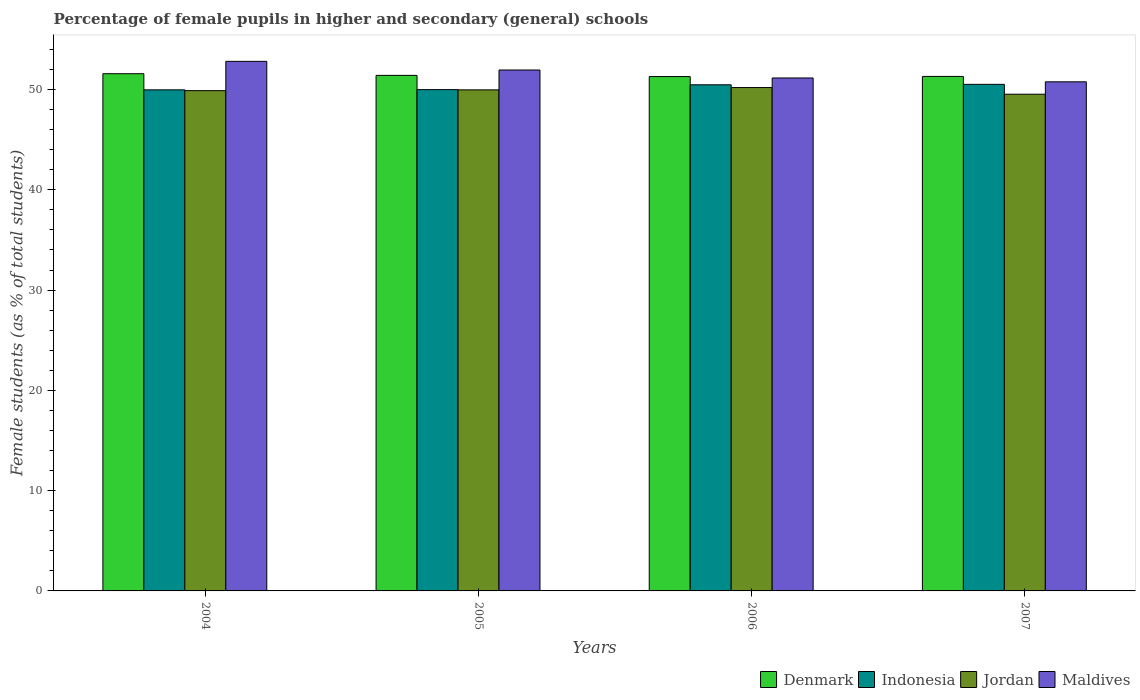How many different coloured bars are there?
Give a very brief answer. 4. Are the number of bars per tick equal to the number of legend labels?
Offer a terse response. Yes. Are the number of bars on each tick of the X-axis equal?
Ensure brevity in your answer.  Yes. What is the label of the 1st group of bars from the left?
Make the answer very short. 2004. In how many cases, is the number of bars for a given year not equal to the number of legend labels?
Offer a very short reply. 0. What is the percentage of female pupils in higher and secondary schools in Maldives in 2005?
Provide a short and direct response. 51.95. Across all years, what is the maximum percentage of female pupils in higher and secondary schools in Indonesia?
Keep it short and to the point. 50.51. Across all years, what is the minimum percentage of female pupils in higher and secondary schools in Maldives?
Your answer should be very brief. 50.77. In which year was the percentage of female pupils in higher and secondary schools in Maldives minimum?
Provide a succinct answer. 2007. What is the total percentage of female pupils in higher and secondary schools in Indonesia in the graph?
Your answer should be compact. 200.94. What is the difference between the percentage of female pupils in higher and secondary schools in Jordan in 2004 and that in 2007?
Offer a very short reply. 0.36. What is the difference between the percentage of female pupils in higher and secondary schools in Jordan in 2005 and the percentage of female pupils in higher and secondary schools in Maldives in 2006?
Your response must be concise. -1.19. What is the average percentage of female pupils in higher and secondary schools in Denmark per year?
Your answer should be compact. 51.39. In the year 2004, what is the difference between the percentage of female pupils in higher and secondary schools in Maldives and percentage of female pupils in higher and secondary schools in Denmark?
Provide a short and direct response. 1.23. What is the ratio of the percentage of female pupils in higher and secondary schools in Denmark in 2004 to that in 2007?
Make the answer very short. 1.01. What is the difference between the highest and the second highest percentage of female pupils in higher and secondary schools in Denmark?
Offer a very short reply. 0.17. What is the difference between the highest and the lowest percentage of female pupils in higher and secondary schools in Maldives?
Your answer should be compact. 2.04. In how many years, is the percentage of female pupils in higher and secondary schools in Maldives greater than the average percentage of female pupils in higher and secondary schools in Maldives taken over all years?
Offer a terse response. 2. Is the sum of the percentage of female pupils in higher and secondary schools in Maldives in 2004 and 2007 greater than the maximum percentage of female pupils in higher and secondary schools in Indonesia across all years?
Your answer should be very brief. Yes. Is it the case that in every year, the sum of the percentage of female pupils in higher and secondary schools in Jordan and percentage of female pupils in higher and secondary schools in Indonesia is greater than the sum of percentage of female pupils in higher and secondary schools in Maldives and percentage of female pupils in higher and secondary schools in Denmark?
Offer a terse response. No. What does the 4th bar from the left in 2007 represents?
Offer a terse response. Maldives. How many bars are there?
Keep it short and to the point. 16. Are all the bars in the graph horizontal?
Ensure brevity in your answer.  No. Are the values on the major ticks of Y-axis written in scientific E-notation?
Provide a short and direct response. No. Does the graph contain grids?
Give a very brief answer. No. What is the title of the graph?
Offer a terse response. Percentage of female pupils in higher and secondary (general) schools. Does "Central Europe" appear as one of the legend labels in the graph?
Keep it short and to the point. No. What is the label or title of the Y-axis?
Offer a terse response. Female students (as % of total students). What is the Female students (as % of total students) of Denmark in 2004?
Ensure brevity in your answer.  51.57. What is the Female students (as % of total students) in Indonesia in 2004?
Provide a succinct answer. 49.97. What is the Female students (as % of total students) in Jordan in 2004?
Give a very brief answer. 49.89. What is the Female students (as % of total students) of Maldives in 2004?
Make the answer very short. 52.81. What is the Female students (as % of total students) in Denmark in 2005?
Keep it short and to the point. 51.41. What is the Female students (as % of total students) of Indonesia in 2005?
Give a very brief answer. 49.99. What is the Female students (as % of total students) of Jordan in 2005?
Your response must be concise. 49.96. What is the Female students (as % of total students) in Maldives in 2005?
Your answer should be very brief. 51.95. What is the Female students (as % of total students) of Denmark in 2006?
Give a very brief answer. 51.29. What is the Female students (as % of total students) of Indonesia in 2006?
Offer a terse response. 50.47. What is the Female students (as % of total students) in Jordan in 2006?
Ensure brevity in your answer.  50.2. What is the Female students (as % of total students) in Maldives in 2006?
Offer a terse response. 51.15. What is the Female students (as % of total students) of Denmark in 2007?
Provide a succinct answer. 51.3. What is the Female students (as % of total students) of Indonesia in 2007?
Your response must be concise. 50.51. What is the Female students (as % of total students) in Jordan in 2007?
Offer a terse response. 49.53. What is the Female students (as % of total students) of Maldives in 2007?
Ensure brevity in your answer.  50.77. Across all years, what is the maximum Female students (as % of total students) in Denmark?
Keep it short and to the point. 51.57. Across all years, what is the maximum Female students (as % of total students) in Indonesia?
Provide a short and direct response. 50.51. Across all years, what is the maximum Female students (as % of total students) in Jordan?
Your response must be concise. 50.2. Across all years, what is the maximum Female students (as % of total students) in Maldives?
Your answer should be compact. 52.81. Across all years, what is the minimum Female students (as % of total students) of Denmark?
Provide a succinct answer. 51.29. Across all years, what is the minimum Female students (as % of total students) of Indonesia?
Your answer should be very brief. 49.97. Across all years, what is the minimum Female students (as % of total students) in Jordan?
Your answer should be very brief. 49.53. Across all years, what is the minimum Female students (as % of total students) in Maldives?
Your answer should be compact. 50.77. What is the total Female students (as % of total students) in Denmark in the graph?
Your answer should be very brief. 205.58. What is the total Female students (as % of total students) in Indonesia in the graph?
Provide a short and direct response. 200.94. What is the total Female students (as % of total students) in Jordan in the graph?
Offer a terse response. 199.58. What is the total Female students (as % of total students) in Maldives in the graph?
Provide a short and direct response. 206.67. What is the difference between the Female students (as % of total students) of Denmark in 2004 and that in 2005?
Provide a short and direct response. 0.17. What is the difference between the Female students (as % of total students) in Indonesia in 2004 and that in 2005?
Provide a short and direct response. -0.02. What is the difference between the Female students (as % of total students) of Jordan in 2004 and that in 2005?
Your answer should be very brief. -0.08. What is the difference between the Female students (as % of total students) in Maldives in 2004 and that in 2005?
Provide a short and direct response. 0.86. What is the difference between the Female students (as % of total students) in Denmark in 2004 and that in 2006?
Offer a terse response. 0.28. What is the difference between the Female students (as % of total students) of Indonesia in 2004 and that in 2006?
Offer a very short reply. -0.5. What is the difference between the Female students (as % of total students) of Jordan in 2004 and that in 2006?
Your answer should be compact. -0.31. What is the difference between the Female students (as % of total students) in Maldives in 2004 and that in 2006?
Offer a very short reply. 1.66. What is the difference between the Female students (as % of total students) of Denmark in 2004 and that in 2007?
Your response must be concise. 0.27. What is the difference between the Female students (as % of total students) in Indonesia in 2004 and that in 2007?
Offer a terse response. -0.55. What is the difference between the Female students (as % of total students) of Jordan in 2004 and that in 2007?
Offer a very short reply. 0.36. What is the difference between the Female students (as % of total students) in Maldives in 2004 and that in 2007?
Offer a very short reply. 2.04. What is the difference between the Female students (as % of total students) in Denmark in 2005 and that in 2006?
Your response must be concise. 0.12. What is the difference between the Female students (as % of total students) in Indonesia in 2005 and that in 2006?
Your answer should be very brief. -0.48. What is the difference between the Female students (as % of total students) of Jordan in 2005 and that in 2006?
Provide a short and direct response. -0.23. What is the difference between the Female students (as % of total students) of Maldives in 2005 and that in 2006?
Offer a terse response. 0.8. What is the difference between the Female students (as % of total students) of Denmark in 2005 and that in 2007?
Ensure brevity in your answer.  0.1. What is the difference between the Female students (as % of total students) of Indonesia in 2005 and that in 2007?
Provide a short and direct response. -0.53. What is the difference between the Female students (as % of total students) in Jordan in 2005 and that in 2007?
Provide a short and direct response. 0.43. What is the difference between the Female students (as % of total students) in Maldives in 2005 and that in 2007?
Provide a succinct answer. 1.18. What is the difference between the Female students (as % of total students) in Denmark in 2006 and that in 2007?
Provide a short and direct response. -0.01. What is the difference between the Female students (as % of total students) in Indonesia in 2006 and that in 2007?
Provide a succinct answer. -0.04. What is the difference between the Female students (as % of total students) of Jordan in 2006 and that in 2007?
Give a very brief answer. 0.67. What is the difference between the Female students (as % of total students) in Maldives in 2006 and that in 2007?
Your response must be concise. 0.38. What is the difference between the Female students (as % of total students) in Denmark in 2004 and the Female students (as % of total students) in Indonesia in 2005?
Offer a very short reply. 1.59. What is the difference between the Female students (as % of total students) of Denmark in 2004 and the Female students (as % of total students) of Jordan in 2005?
Provide a short and direct response. 1.61. What is the difference between the Female students (as % of total students) of Denmark in 2004 and the Female students (as % of total students) of Maldives in 2005?
Your response must be concise. -0.37. What is the difference between the Female students (as % of total students) of Indonesia in 2004 and the Female students (as % of total students) of Jordan in 2005?
Your answer should be very brief. 0. What is the difference between the Female students (as % of total students) in Indonesia in 2004 and the Female students (as % of total students) in Maldives in 2005?
Offer a very short reply. -1.98. What is the difference between the Female students (as % of total students) in Jordan in 2004 and the Female students (as % of total students) in Maldives in 2005?
Make the answer very short. -2.06. What is the difference between the Female students (as % of total students) in Denmark in 2004 and the Female students (as % of total students) in Indonesia in 2006?
Provide a short and direct response. 1.1. What is the difference between the Female students (as % of total students) in Denmark in 2004 and the Female students (as % of total students) in Jordan in 2006?
Your answer should be compact. 1.38. What is the difference between the Female students (as % of total students) in Denmark in 2004 and the Female students (as % of total students) in Maldives in 2006?
Your response must be concise. 0.42. What is the difference between the Female students (as % of total students) in Indonesia in 2004 and the Female students (as % of total students) in Jordan in 2006?
Provide a short and direct response. -0.23. What is the difference between the Female students (as % of total students) in Indonesia in 2004 and the Female students (as % of total students) in Maldives in 2006?
Ensure brevity in your answer.  -1.18. What is the difference between the Female students (as % of total students) in Jordan in 2004 and the Female students (as % of total students) in Maldives in 2006?
Give a very brief answer. -1.26. What is the difference between the Female students (as % of total students) of Denmark in 2004 and the Female students (as % of total students) of Indonesia in 2007?
Ensure brevity in your answer.  1.06. What is the difference between the Female students (as % of total students) of Denmark in 2004 and the Female students (as % of total students) of Jordan in 2007?
Provide a short and direct response. 2.04. What is the difference between the Female students (as % of total students) of Denmark in 2004 and the Female students (as % of total students) of Maldives in 2007?
Offer a very short reply. 0.81. What is the difference between the Female students (as % of total students) of Indonesia in 2004 and the Female students (as % of total students) of Jordan in 2007?
Provide a succinct answer. 0.44. What is the difference between the Female students (as % of total students) of Indonesia in 2004 and the Female students (as % of total students) of Maldives in 2007?
Offer a very short reply. -0.8. What is the difference between the Female students (as % of total students) of Jordan in 2004 and the Female students (as % of total students) of Maldives in 2007?
Give a very brief answer. -0.88. What is the difference between the Female students (as % of total students) in Denmark in 2005 and the Female students (as % of total students) in Indonesia in 2006?
Your answer should be compact. 0.94. What is the difference between the Female students (as % of total students) in Denmark in 2005 and the Female students (as % of total students) in Jordan in 2006?
Provide a short and direct response. 1.21. What is the difference between the Female students (as % of total students) in Denmark in 2005 and the Female students (as % of total students) in Maldives in 2006?
Keep it short and to the point. 0.26. What is the difference between the Female students (as % of total students) of Indonesia in 2005 and the Female students (as % of total students) of Jordan in 2006?
Keep it short and to the point. -0.21. What is the difference between the Female students (as % of total students) in Indonesia in 2005 and the Female students (as % of total students) in Maldives in 2006?
Give a very brief answer. -1.16. What is the difference between the Female students (as % of total students) in Jordan in 2005 and the Female students (as % of total students) in Maldives in 2006?
Ensure brevity in your answer.  -1.19. What is the difference between the Female students (as % of total students) in Denmark in 2005 and the Female students (as % of total students) in Indonesia in 2007?
Your response must be concise. 0.89. What is the difference between the Female students (as % of total students) in Denmark in 2005 and the Female students (as % of total students) in Jordan in 2007?
Ensure brevity in your answer.  1.88. What is the difference between the Female students (as % of total students) in Denmark in 2005 and the Female students (as % of total students) in Maldives in 2007?
Keep it short and to the point. 0.64. What is the difference between the Female students (as % of total students) in Indonesia in 2005 and the Female students (as % of total students) in Jordan in 2007?
Your answer should be very brief. 0.46. What is the difference between the Female students (as % of total students) in Indonesia in 2005 and the Female students (as % of total students) in Maldives in 2007?
Offer a terse response. -0.78. What is the difference between the Female students (as % of total students) in Jordan in 2005 and the Female students (as % of total students) in Maldives in 2007?
Your response must be concise. -0.8. What is the difference between the Female students (as % of total students) in Denmark in 2006 and the Female students (as % of total students) in Indonesia in 2007?
Provide a succinct answer. 0.78. What is the difference between the Female students (as % of total students) of Denmark in 2006 and the Female students (as % of total students) of Jordan in 2007?
Provide a short and direct response. 1.76. What is the difference between the Female students (as % of total students) in Denmark in 2006 and the Female students (as % of total students) in Maldives in 2007?
Provide a short and direct response. 0.52. What is the difference between the Female students (as % of total students) in Indonesia in 2006 and the Female students (as % of total students) in Jordan in 2007?
Provide a short and direct response. 0.94. What is the difference between the Female students (as % of total students) of Indonesia in 2006 and the Female students (as % of total students) of Maldives in 2007?
Your answer should be compact. -0.3. What is the difference between the Female students (as % of total students) of Jordan in 2006 and the Female students (as % of total students) of Maldives in 2007?
Your answer should be compact. -0.57. What is the average Female students (as % of total students) of Denmark per year?
Your response must be concise. 51.39. What is the average Female students (as % of total students) in Indonesia per year?
Offer a terse response. 50.23. What is the average Female students (as % of total students) in Jordan per year?
Offer a very short reply. 49.89. What is the average Female students (as % of total students) of Maldives per year?
Your response must be concise. 51.67. In the year 2004, what is the difference between the Female students (as % of total students) in Denmark and Female students (as % of total students) in Indonesia?
Give a very brief answer. 1.61. In the year 2004, what is the difference between the Female students (as % of total students) of Denmark and Female students (as % of total students) of Jordan?
Provide a short and direct response. 1.69. In the year 2004, what is the difference between the Female students (as % of total students) of Denmark and Female students (as % of total students) of Maldives?
Provide a short and direct response. -1.23. In the year 2004, what is the difference between the Female students (as % of total students) in Indonesia and Female students (as % of total students) in Jordan?
Your response must be concise. 0.08. In the year 2004, what is the difference between the Female students (as % of total students) of Indonesia and Female students (as % of total students) of Maldives?
Offer a terse response. -2.84. In the year 2004, what is the difference between the Female students (as % of total students) of Jordan and Female students (as % of total students) of Maldives?
Ensure brevity in your answer.  -2.92. In the year 2005, what is the difference between the Female students (as % of total students) of Denmark and Female students (as % of total students) of Indonesia?
Your response must be concise. 1.42. In the year 2005, what is the difference between the Female students (as % of total students) in Denmark and Female students (as % of total students) in Jordan?
Offer a terse response. 1.44. In the year 2005, what is the difference between the Female students (as % of total students) of Denmark and Female students (as % of total students) of Maldives?
Keep it short and to the point. -0.54. In the year 2005, what is the difference between the Female students (as % of total students) in Indonesia and Female students (as % of total students) in Jordan?
Your answer should be very brief. 0.02. In the year 2005, what is the difference between the Female students (as % of total students) of Indonesia and Female students (as % of total students) of Maldives?
Ensure brevity in your answer.  -1.96. In the year 2005, what is the difference between the Female students (as % of total students) of Jordan and Female students (as % of total students) of Maldives?
Your response must be concise. -1.98. In the year 2006, what is the difference between the Female students (as % of total students) in Denmark and Female students (as % of total students) in Indonesia?
Provide a succinct answer. 0.82. In the year 2006, what is the difference between the Female students (as % of total students) in Denmark and Female students (as % of total students) in Jordan?
Provide a succinct answer. 1.09. In the year 2006, what is the difference between the Female students (as % of total students) in Denmark and Female students (as % of total students) in Maldives?
Provide a short and direct response. 0.14. In the year 2006, what is the difference between the Female students (as % of total students) in Indonesia and Female students (as % of total students) in Jordan?
Keep it short and to the point. 0.27. In the year 2006, what is the difference between the Female students (as % of total students) of Indonesia and Female students (as % of total students) of Maldives?
Offer a very short reply. -0.68. In the year 2006, what is the difference between the Female students (as % of total students) of Jordan and Female students (as % of total students) of Maldives?
Your response must be concise. -0.95. In the year 2007, what is the difference between the Female students (as % of total students) in Denmark and Female students (as % of total students) in Indonesia?
Your answer should be very brief. 0.79. In the year 2007, what is the difference between the Female students (as % of total students) of Denmark and Female students (as % of total students) of Jordan?
Give a very brief answer. 1.77. In the year 2007, what is the difference between the Female students (as % of total students) in Denmark and Female students (as % of total students) in Maldives?
Ensure brevity in your answer.  0.54. In the year 2007, what is the difference between the Female students (as % of total students) in Indonesia and Female students (as % of total students) in Jordan?
Offer a terse response. 0.98. In the year 2007, what is the difference between the Female students (as % of total students) in Indonesia and Female students (as % of total students) in Maldives?
Keep it short and to the point. -0.25. In the year 2007, what is the difference between the Female students (as % of total students) of Jordan and Female students (as % of total students) of Maldives?
Your answer should be compact. -1.24. What is the ratio of the Female students (as % of total students) in Denmark in 2004 to that in 2005?
Your answer should be compact. 1. What is the ratio of the Female students (as % of total students) in Jordan in 2004 to that in 2005?
Keep it short and to the point. 1. What is the ratio of the Female students (as % of total students) in Maldives in 2004 to that in 2005?
Give a very brief answer. 1.02. What is the ratio of the Female students (as % of total students) in Denmark in 2004 to that in 2006?
Offer a terse response. 1.01. What is the ratio of the Female students (as % of total students) in Jordan in 2004 to that in 2006?
Your response must be concise. 0.99. What is the ratio of the Female students (as % of total students) of Maldives in 2004 to that in 2006?
Ensure brevity in your answer.  1.03. What is the ratio of the Female students (as % of total students) in Denmark in 2004 to that in 2007?
Provide a short and direct response. 1.01. What is the ratio of the Female students (as % of total students) of Indonesia in 2004 to that in 2007?
Keep it short and to the point. 0.99. What is the ratio of the Female students (as % of total students) in Maldives in 2004 to that in 2007?
Keep it short and to the point. 1.04. What is the ratio of the Female students (as % of total students) in Denmark in 2005 to that in 2006?
Provide a short and direct response. 1. What is the ratio of the Female students (as % of total students) of Indonesia in 2005 to that in 2006?
Provide a short and direct response. 0.99. What is the ratio of the Female students (as % of total students) in Jordan in 2005 to that in 2006?
Make the answer very short. 1. What is the ratio of the Female students (as % of total students) of Maldives in 2005 to that in 2006?
Provide a short and direct response. 1.02. What is the ratio of the Female students (as % of total students) of Indonesia in 2005 to that in 2007?
Offer a very short reply. 0.99. What is the ratio of the Female students (as % of total students) of Jordan in 2005 to that in 2007?
Offer a very short reply. 1.01. What is the ratio of the Female students (as % of total students) of Maldives in 2005 to that in 2007?
Provide a succinct answer. 1.02. What is the ratio of the Female students (as % of total students) of Indonesia in 2006 to that in 2007?
Make the answer very short. 1. What is the ratio of the Female students (as % of total students) in Jordan in 2006 to that in 2007?
Your answer should be very brief. 1.01. What is the ratio of the Female students (as % of total students) of Maldives in 2006 to that in 2007?
Ensure brevity in your answer.  1.01. What is the difference between the highest and the second highest Female students (as % of total students) of Indonesia?
Give a very brief answer. 0.04. What is the difference between the highest and the second highest Female students (as % of total students) in Jordan?
Your response must be concise. 0.23. What is the difference between the highest and the second highest Female students (as % of total students) in Maldives?
Provide a short and direct response. 0.86. What is the difference between the highest and the lowest Female students (as % of total students) of Denmark?
Provide a succinct answer. 0.28. What is the difference between the highest and the lowest Female students (as % of total students) in Indonesia?
Ensure brevity in your answer.  0.55. What is the difference between the highest and the lowest Female students (as % of total students) of Jordan?
Provide a succinct answer. 0.67. What is the difference between the highest and the lowest Female students (as % of total students) in Maldives?
Offer a very short reply. 2.04. 